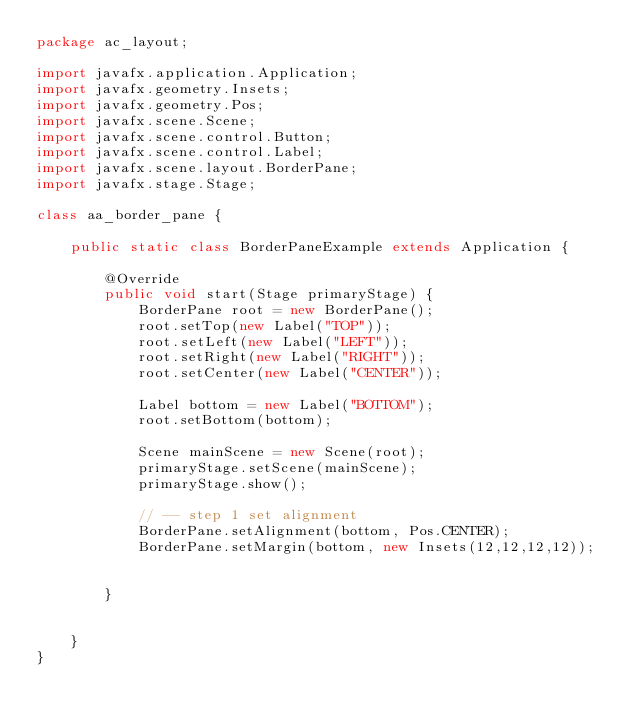Convert code to text. <code><loc_0><loc_0><loc_500><loc_500><_Java_>package ac_layout;

import javafx.application.Application;
import javafx.geometry.Insets;
import javafx.geometry.Pos;
import javafx.scene.Scene;
import javafx.scene.control.Button;
import javafx.scene.control.Label;
import javafx.scene.layout.BorderPane;
import javafx.stage.Stage;

class aa_border_pane {

    public static class BorderPaneExample extends Application {

        @Override
        public void start(Stage primaryStage) {
            BorderPane root = new BorderPane();
            root.setTop(new Label("TOP"));
            root.setLeft(new Label("LEFT"));
            root.setRight(new Label("RIGHT"));
            root.setCenter(new Label("CENTER"));

            Label bottom = new Label("BOTTOM");
            root.setBottom(bottom);

            Scene mainScene = new Scene(root);
            primaryStage.setScene(mainScene);
            primaryStage.show();

            // -- step 1 set alignment
            BorderPane.setAlignment(bottom, Pos.CENTER);
            BorderPane.setMargin(bottom, new Insets(12,12,12,12));


        }


    }
}
</code> 